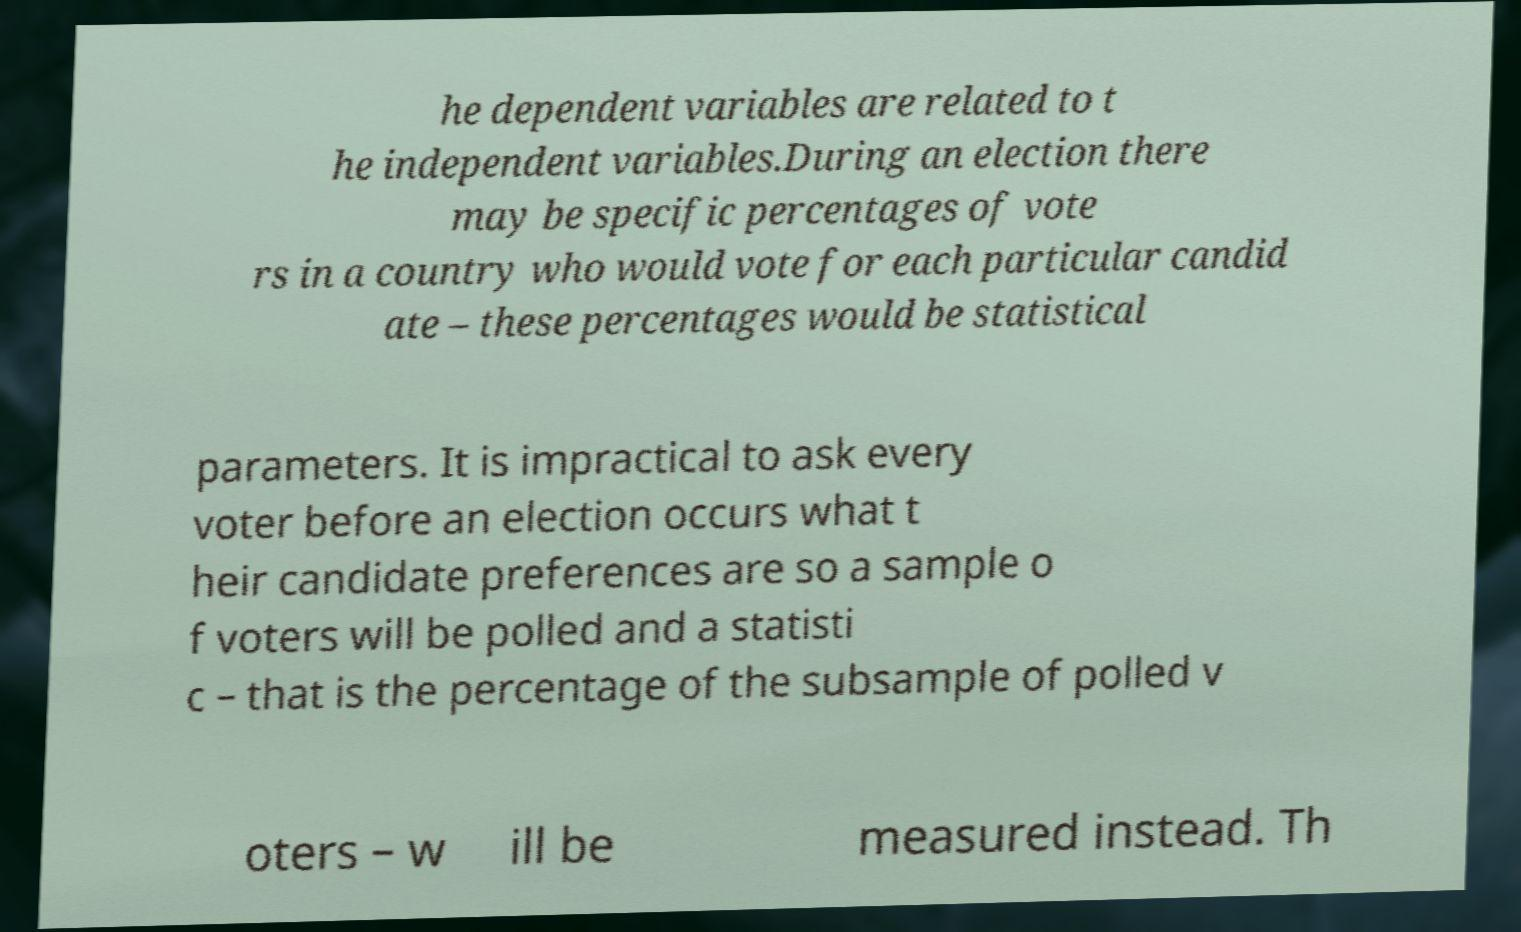Could you assist in decoding the text presented in this image and type it out clearly? he dependent variables are related to t he independent variables.During an election there may be specific percentages of vote rs in a country who would vote for each particular candid ate – these percentages would be statistical parameters. It is impractical to ask every voter before an election occurs what t heir candidate preferences are so a sample o f voters will be polled and a statisti c – that is the percentage of the subsample of polled v oters – w ill be measured instead. Th 